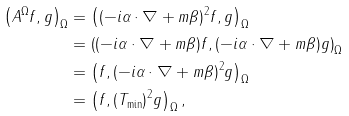Convert formula to latex. <formula><loc_0><loc_0><loc_500><loc_500>\left ( A ^ { \Omega } f , g \right ) _ { \Omega } & = \left ( ( - i \alpha \cdot \nabla + m \beta ) ^ { 2 } f , g \right ) _ { \Omega } \\ & = \left ( ( - i \alpha \cdot \nabla + m \beta ) f , ( - i \alpha \cdot \nabla + m \beta ) g \right ) _ { \Omega } \\ & = \left ( f , ( - i \alpha \cdot \nabla + m \beta ) ^ { 2 } g \right ) _ { \Omega } \\ & = \left ( f , ( T _ { \min } ) ^ { 2 } g \right ) _ { \Omega } ,</formula> 